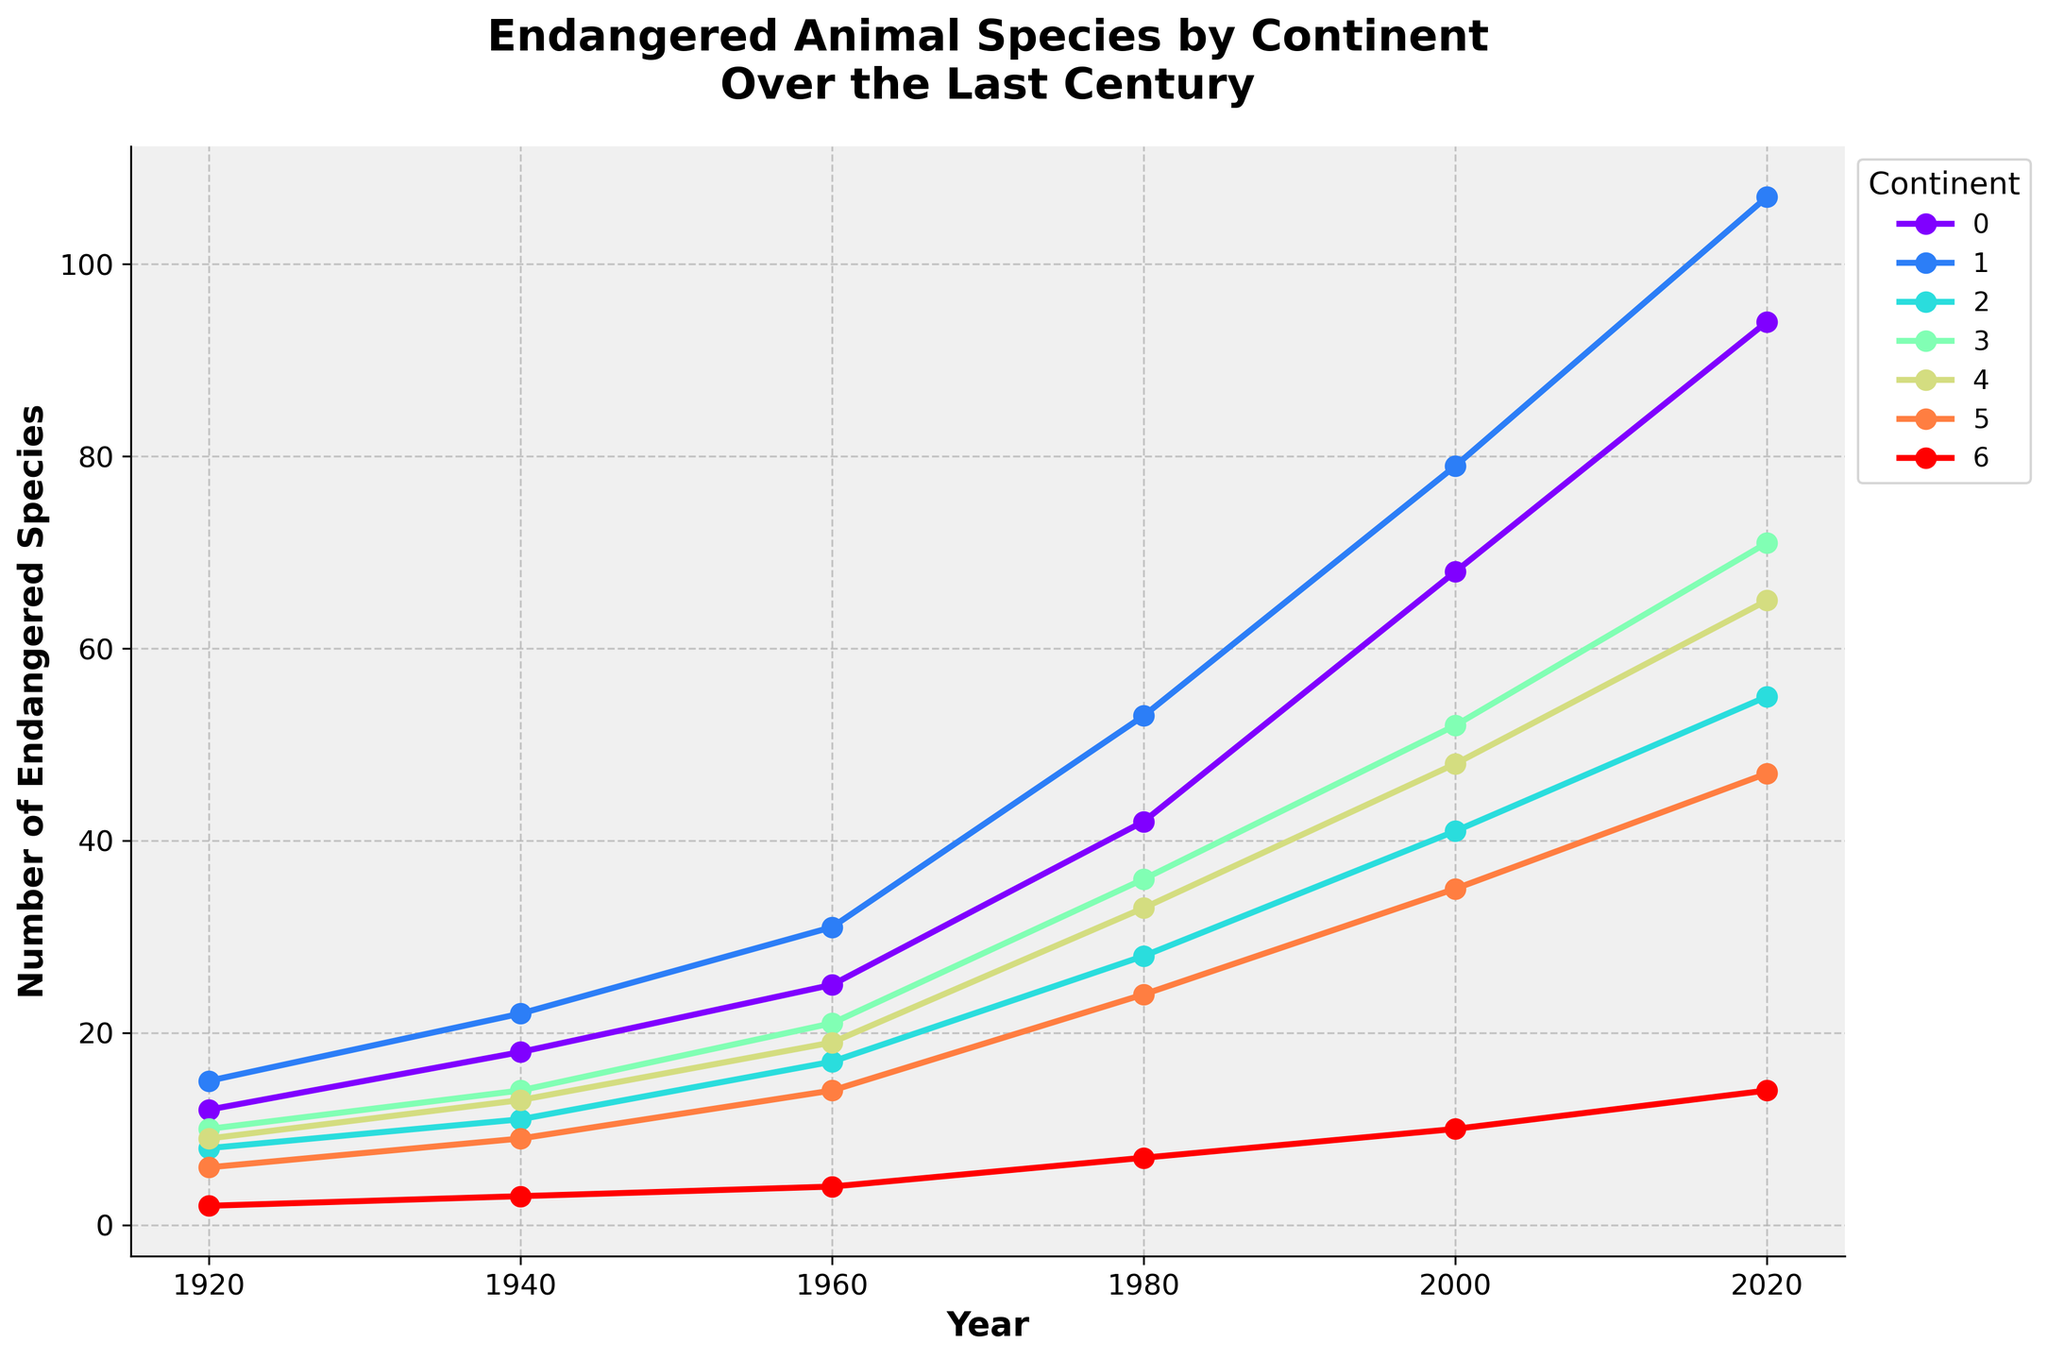Which continent had the highest number of endangered species in 2020? By looking at the endpoints of each line on the rightmost side of the chart (representing 2020), we can identify the highest value, which corresponds to Asia.
Answer: Asia How did the number of endangered species in Africa change from 1920 to 2020? Locate Africa's line on the chart. In 1920, the number is at 12; in 2020, it is at 94. The difference is 94 - 12 = 82.
Answer: Increased by 82 Which continent had the least increase in endangered species from 1920 to 2020? Calculate the increase for each continent: Africa (94-12=82), Asia (107-15=92), Europe (55-8=47), North America (71-10=61), South America (65-9=56), Oceania (47-6=41), Antarctica (14-2=12). The least increase is in Antarctica, with 12.
Answer: Antarctica What is the approximate average number of endangered species in Europe between 1920 and 2020? Sum the values in Europe’s line: 8, 11, 17, 28, 41, 55. The sum is 160. Divide by the number of data points (6): 160/6 ≈ 26.67.
Answer: 26.67 Which continents had more endangered species than Antarctica in 1980? Find Antarctica’s value in 1980: 7. Compare the 1980 values for other continents: Africa (42), Asia (53), Europe (28), North America (36), South America (33), Oceania (24). All have more than 7.
Answer: Africa, Asia, Europe, North America, South America, Oceania Between Asia and North America, which continent saw a greater absolute increase in endangered species from 1960 to 2020? Calculate the increase for each: Asia (107-31=76), North America (71-21=50). Asia saw a greater increase.
Answer: Asia Which continent's line is steepest between 2000 and 2020? The steepness of the line represents the rate of increase. Observe the slope between 2000 and 2020 for each continent: Africa, Asia, Europe, North America, South America, Oceania, and Antarctica. The steepest line is that of Asia.
Answer: Asia 